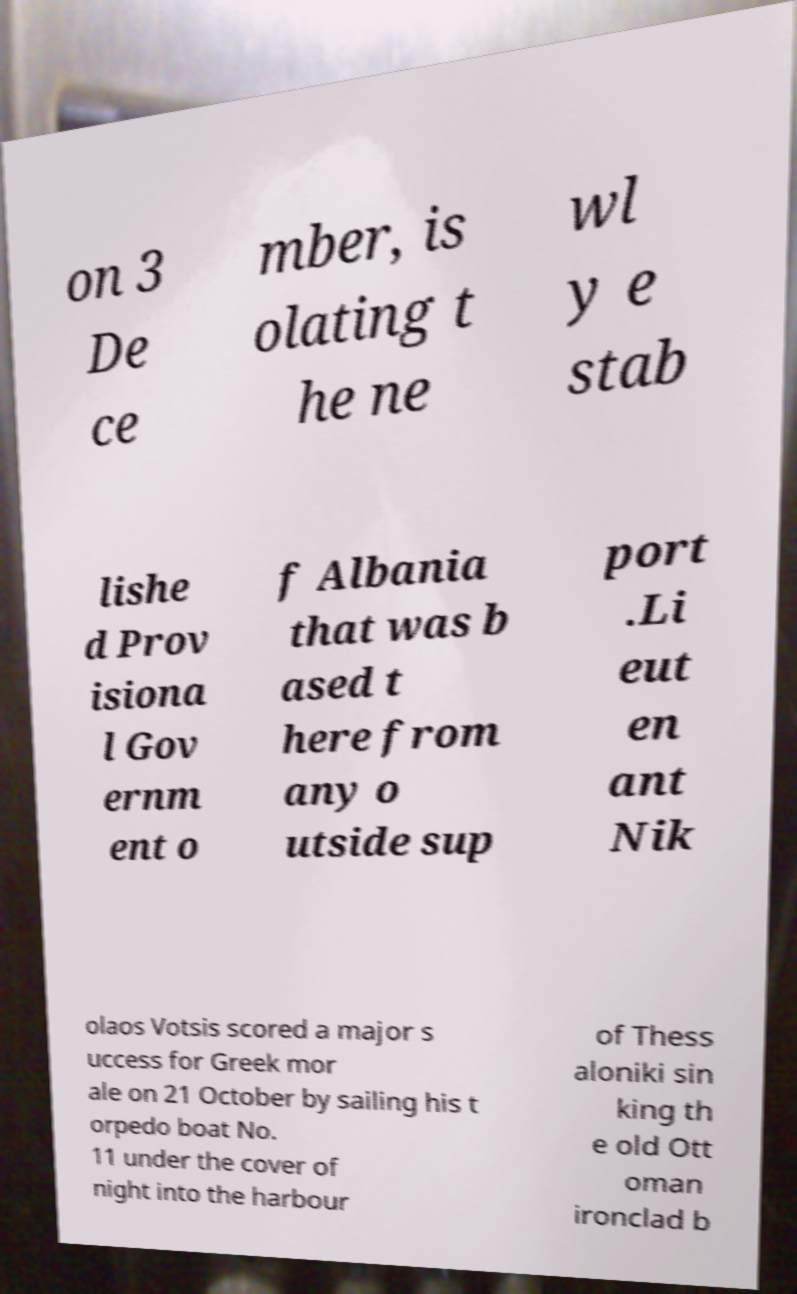Please read and relay the text visible in this image. What does it say? on 3 De ce mber, is olating t he ne wl y e stab lishe d Prov isiona l Gov ernm ent o f Albania that was b ased t here from any o utside sup port .Li eut en ant Nik olaos Votsis scored a major s uccess for Greek mor ale on 21 October by sailing his t orpedo boat No. 11 under the cover of night into the harbour of Thess aloniki sin king th e old Ott oman ironclad b 